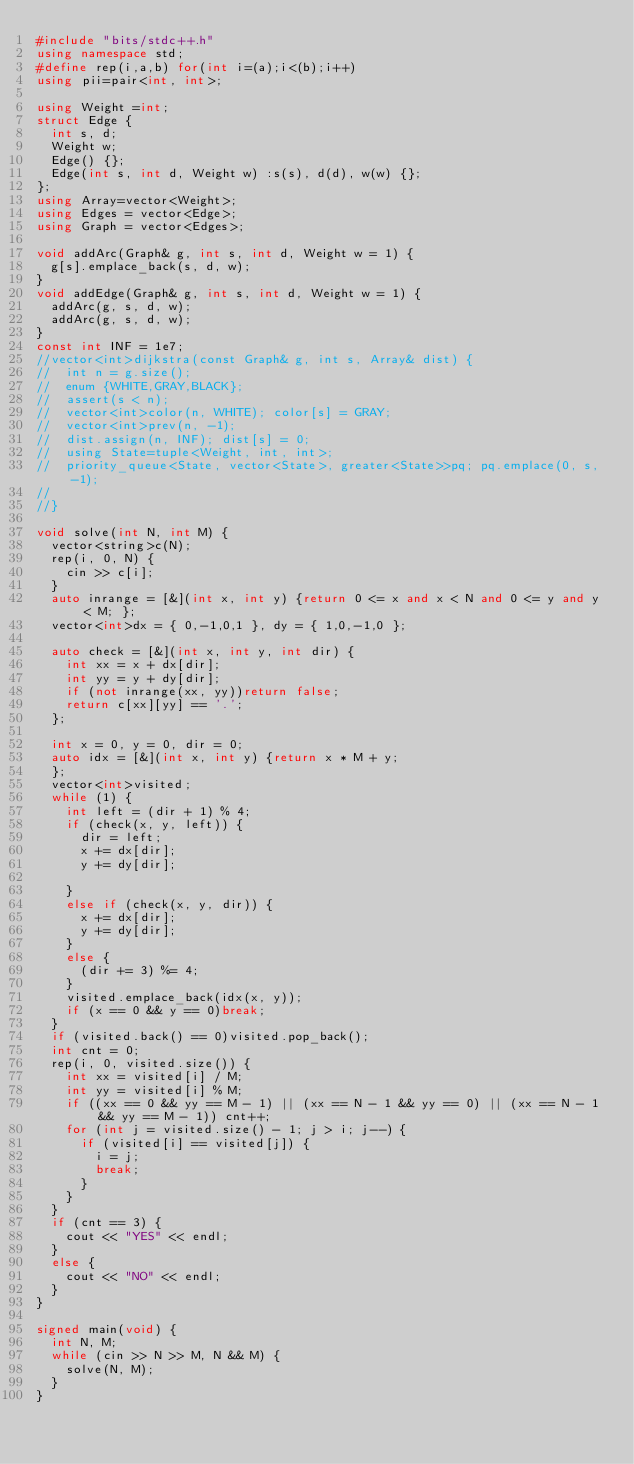Convert code to text. <code><loc_0><loc_0><loc_500><loc_500><_C++_>#include "bits/stdc++.h"
using namespace std;
#define rep(i,a,b) for(int i=(a);i<(b);i++)
using pii=pair<int, int>;

using Weight =int;
struct Edge {
	int s, d;
	Weight w;
	Edge() {};
	Edge(int s, int d, Weight w) :s(s), d(d), w(w) {};
};
using Array=vector<Weight>;
using Edges = vector<Edge>;
using Graph = vector<Edges>;

void addArc(Graph& g, int s, int d, Weight w = 1) {
	g[s].emplace_back(s, d, w);
}
void addEdge(Graph& g, int s, int d, Weight w = 1) {
	addArc(g, s, d, w);
	addArc(g, s, d, w);
}
const int INF = 1e7;
//vector<int>dijkstra(const Graph& g, int s, Array& dist) {
//	int n = g.size();
//	enum {WHITE,GRAY,BLACK};
//	assert(s < n);
//	vector<int>color(n, WHITE); color[s] = GRAY;
//	vector<int>prev(n, -1);
//	dist.assign(n, INF); dist[s] = 0;
//	using State=tuple<Weight, int, int>;
//	priority_queue<State, vector<State>, greater<State>>pq; pq.emplace(0, s, -1);
//
//}

void solve(int N, int M) {
	vector<string>c(N);
	rep(i, 0, N) {
		cin >> c[i];
	}
	auto inrange = [&](int x, int y) {return 0 <= x and x < N and 0 <= y and y < M; };
	vector<int>dx = { 0,-1,0,1 }, dy = { 1,0,-1,0 };

	auto check = [&](int x, int y, int dir) {
		int xx = x + dx[dir];
		int yy = y + dy[dir];
		if (not inrange(xx, yy))return false;
		return c[xx][yy] == '.';
	};

	int x = 0, y = 0, dir = 0;
	auto idx = [&](int x, int y) {return x * M + y;
	};
	vector<int>visited;
	while (1) {
		int left = (dir + 1) % 4;
		if (check(x, y, left)) {
			dir = left;
			x += dx[dir];
			y += dy[dir];

		}
		else if (check(x, y, dir)) {
			x += dx[dir];
			y += dy[dir];
		}
		else {
			(dir += 3) %= 4;
		}
		visited.emplace_back(idx(x, y));
		if (x == 0 && y == 0)break;
	}
	if (visited.back() == 0)visited.pop_back();
	int cnt = 0;
	rep(i, 0, visited.size()) {
		int xx = visited[i] / M;
		int yy = visited[i] % M;
		if ((xx == 0 && yy == M - 1) || (xx == N - 1 && yy == 0) || (xx == N - 1 && yy == M - 1)) cnt++;
		for (int j = visited.size() - 1; j > i; j--) {
			if (visited[i] == visited[j]) {
				i = j;
				break;
			}
		}
	}
	if (cnt == 3) {
		cout << "YES" << endl;
	}
	else {
		cout << "NO" << endl;
	}
}

signed main(void) {
	int N, M;
	while (cin >> N >> M, N && M) {
		solve(N, M);
	}
}
</code> 